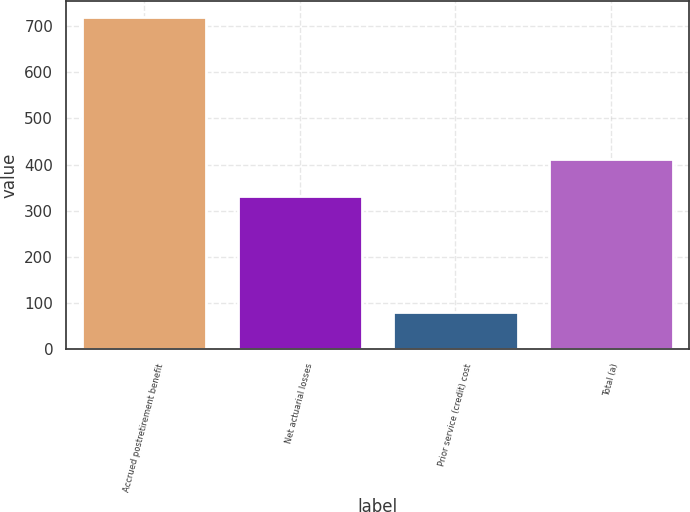Convert chart to OTSL. <chart><loc_0><loc_0><loc_500><loc_500><bar_chart><fcel>Accrued postretirement benefit<fcel>Net actuarial losses<fcel>Prior service (credit) cost<fcel>Total (a)<nl><fcel>719<fcel>331<fcel>81<fcel>412<nl></chart> 